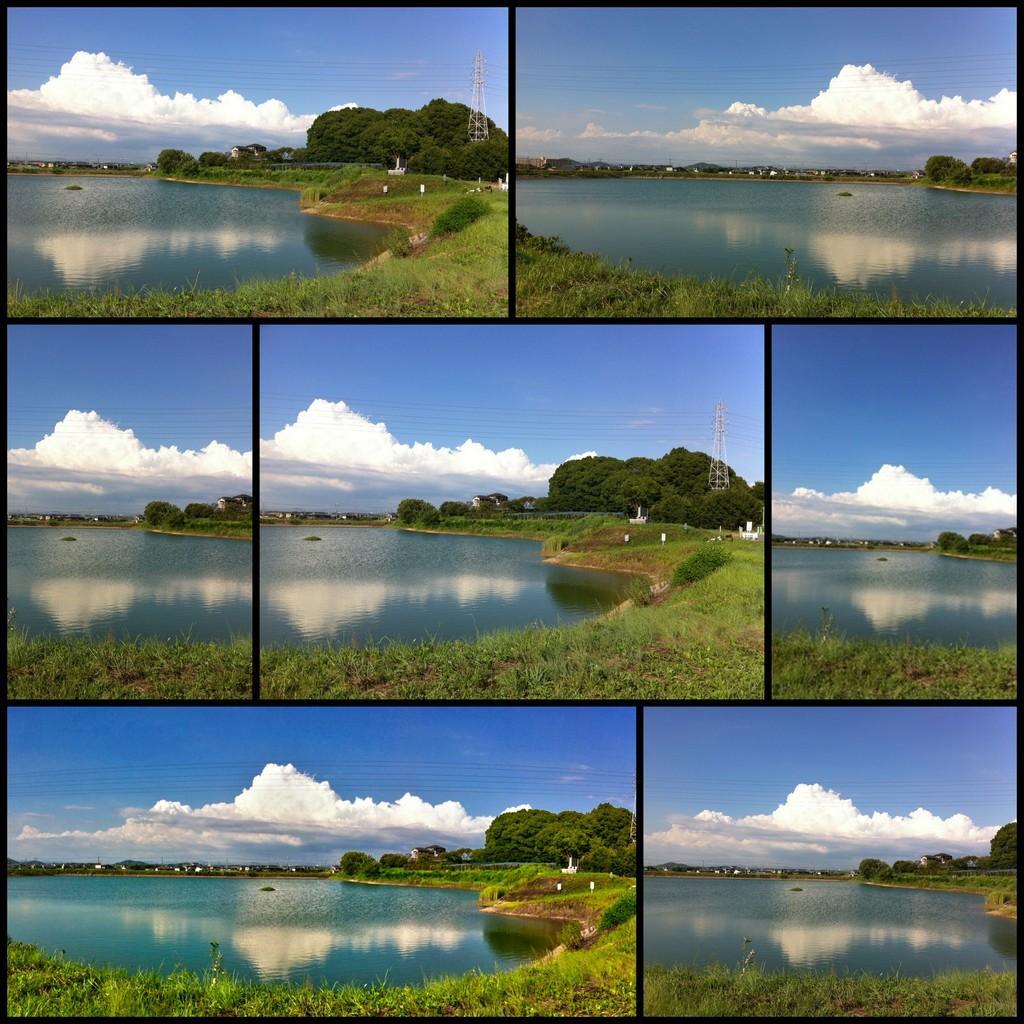Please provide a concise description of this image. In this image I can see collage photos where I can see water, grass, number of trees, wires, clouds, the sky and towers. 